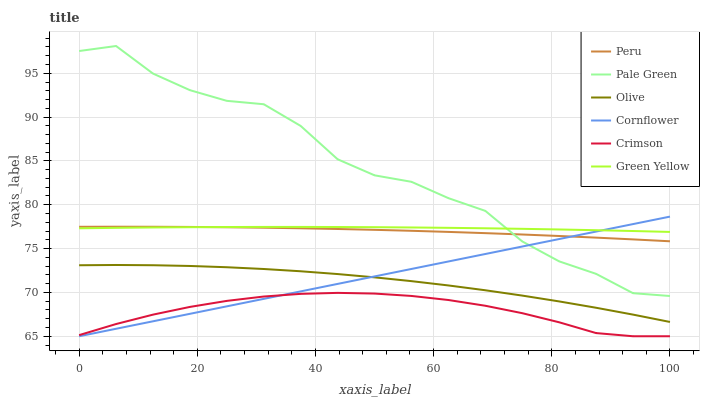Does Crimson have the minimum area under the curve?
Answer yes or no. Yes. Does Pale Green have the maximum area under the curve?
Answer yes or no. Yes. Does Pale Green have the minimum area under the curve?
Answer yes or no. No. Does Crimson have the maximum area under the curve?
Answer yes or no. No. Is Cornflower the smoothest?
Answer yes or no. Yes. Is Pale Green the roughest?
Answer yes or no. Yes. Is Crimson the smoothest?
Answer yes or no. No. Is Crimson the roughest?
Answer yes or no. No. Does Cornflower have the lowest value?
Answer yes or no. Yes. Does Pale Green have the lowest value?
Answer yes or no. No. Does Pale Green have the highest value?
Answer yes or no. Yes. Does Crimson have the highest value?
Answer yes or no. No. Is Olive less than Green Yellow?
Answer yes or no. Yes. Is Peru greater than Crimson?
Answer yes or no. Yes. Does Peru intersect Green Yellow?
Answer yes or no. Yes. Is Peru less than Green Yellow?
Answer yes or no. No. Is Peru greater than Green Yellow?
Answer yes or no. No. Does Olive intersect Green Yellow?
Answer yes or no. No. 